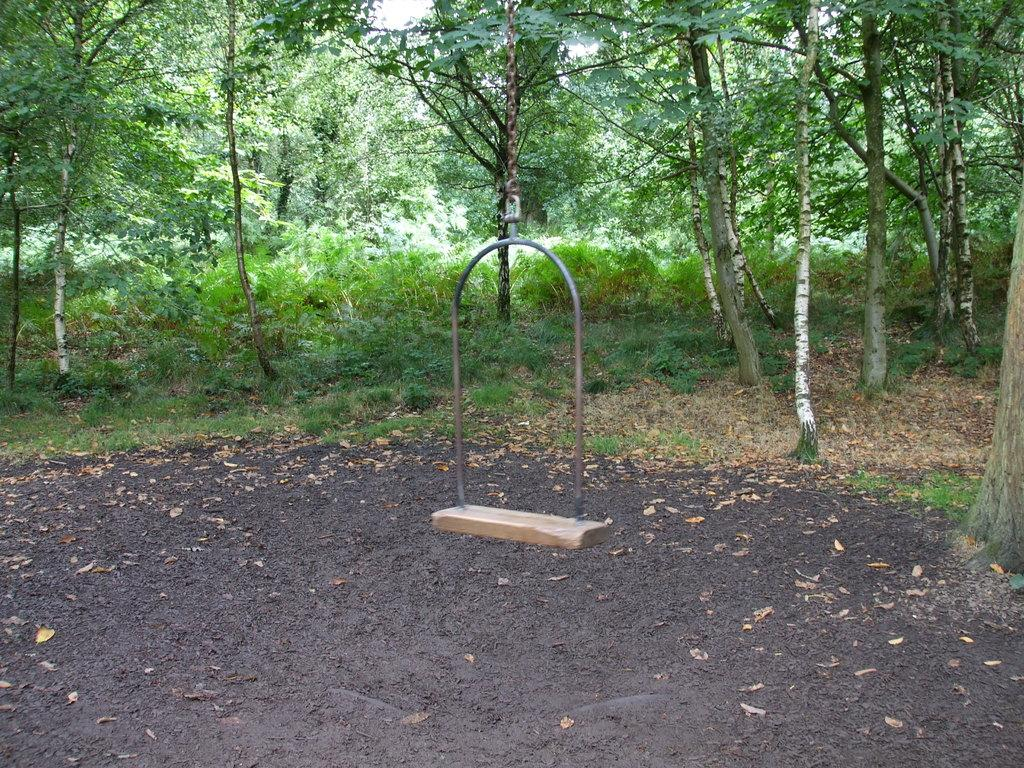What is the main object in the image? There is a swing in the image. How is the swing supported? The swing is hanging from a tree. What type of vegetation is visible in the image? Leaves, plants, and trees are visible in the image. What page of the book is the person reading on the swing? There is no person or book present in the image, so it is not possible to determine which page they might be reading. 